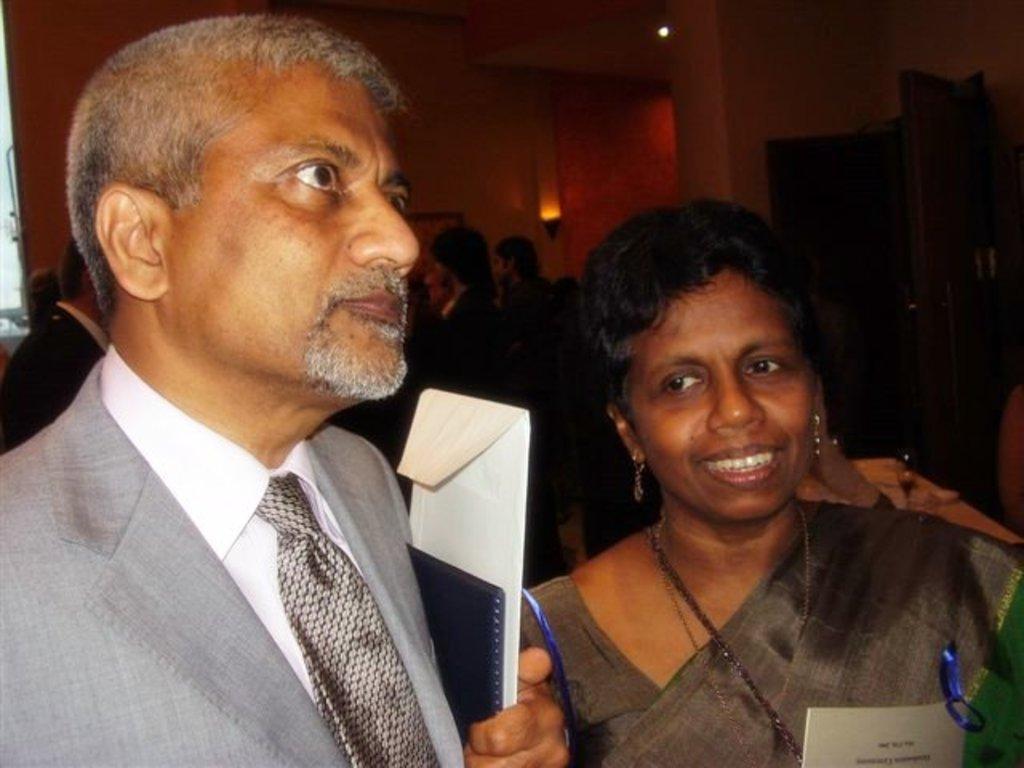Can you describe this image briefly? In this image I can see one woman and man and woman mouth open and in the background I can see few persons and the wall and the light and beam and man holding a cover. 